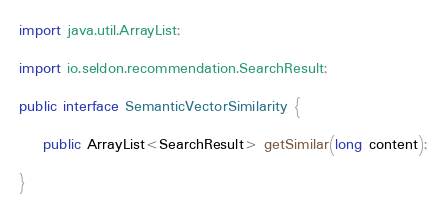<code> <loc_0><loc_0><loc_500><loc_500><_Java_>
import java.util.ArrayList;

import io.seldon.recommendation.SearchResult;

public interface SemanticVectorSimilarity {

	public ArrayList<SearchResult> getSimilar(long content);
	
}
</code> 